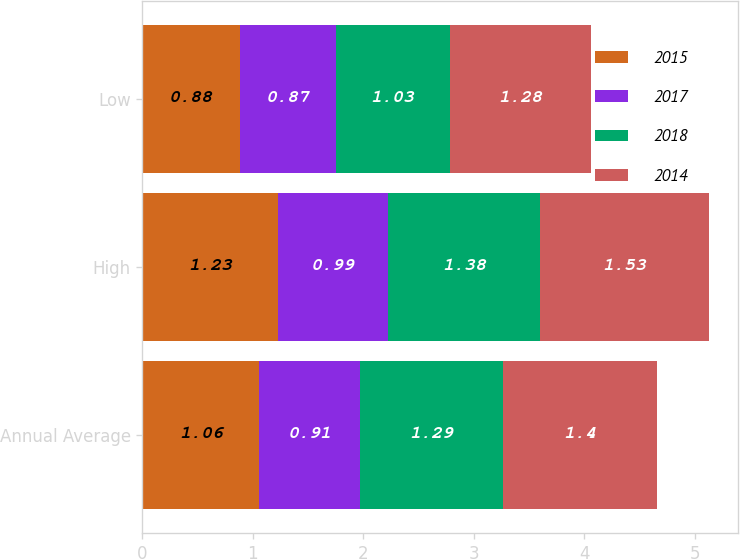Convert chart to OTSL. <chart><loc_0><loc_0><loc_500><loc_500><stacked_bar_chart><ecel><fcel>Annual Average<fcel>High<fcel>Low<nl><fcel>2015<fcel>1.06<fcel>1.23<fcel>0.88<nl><fcel>2017<fcel>0.91<fcel>0.99<fcel>0.87<nl><fcel>2018<fcel>1.29<fcel>1.38<fcel>1.03<nl><fcel>2014<fcel>1.4<fcel>1.53<fcel>1.28<nl></chart> 